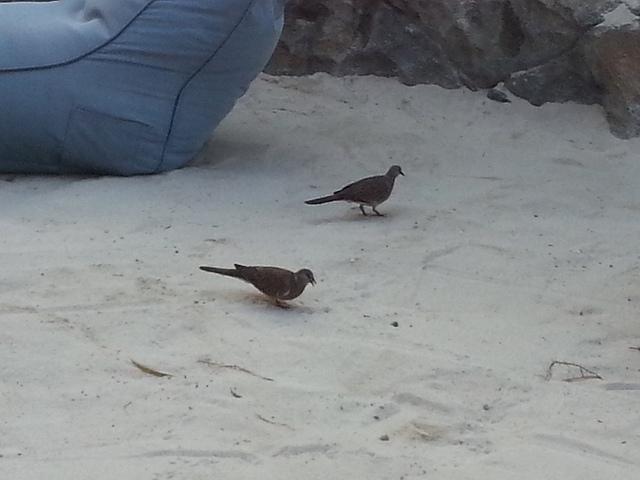How many birds are there?
Give a very brief answer. 2. How many people are floating in water?
Give a very brief answer. 0. 